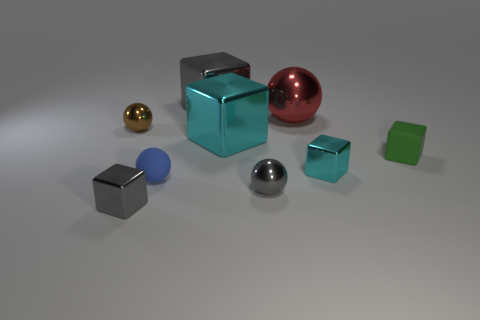Subtract 2 cubes. How many cubes are left? 3 Subtract all green cubes. How many cubes are left? 4 Subtract all small rubber cubes. How many cubes are left? 4 Subtract all purple blocks. Subtract all blue spheres. How many blocks are left? 5 Add 1 small cyan metal cubes. How many objects exist? 10 Subtract all spheres. How many objects are left? 5 Add 9 tiny brown rubber balls. How many tiny brown rubber balls exist? 9 Subtract 0 blue blocks. How many objects are left? 9 Subtract all green cubes. Subtract all brown matte cylinders. How many objects are left? 8 Add 7 green cubes. How many green cubes are left? 8 